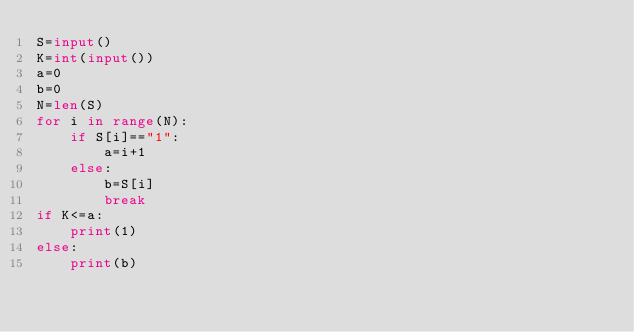Convert code to text. <code><loc_0><loc_0><loc_500><loc_500><_Python_>S=input()
K=int(input())
a=0
b=0
N=len(S)
for i in range(N):
    if S[i]=="1":
        a=i+1
    else:
        b=S[i]
        break
if K<=a:
    print(1)
else:
    print(b)
</code> 